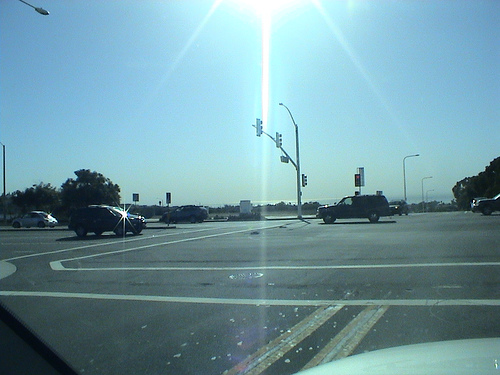<image>What color is the traffic light? It is ambiguous what color the traffic light is. It could be either red or green. What color is the traffic light? I am not sure what color is the traffic light. It can be seen both green and red. 